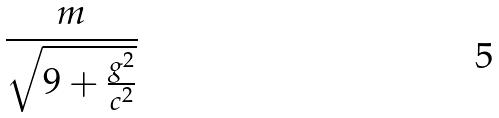<formula> <loc_0><loc_0><loc_500><loc_500>\frac { m } { \sqrt { 9 + \frac { g ^ { 2 } } { c ^ { 2 } } } }</formula> 